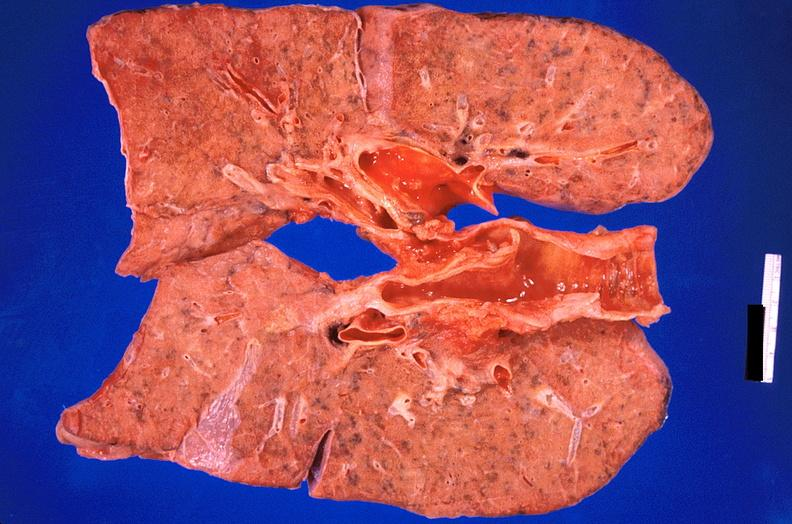where is this?
Answer the question using a single word or phrase. Lung 